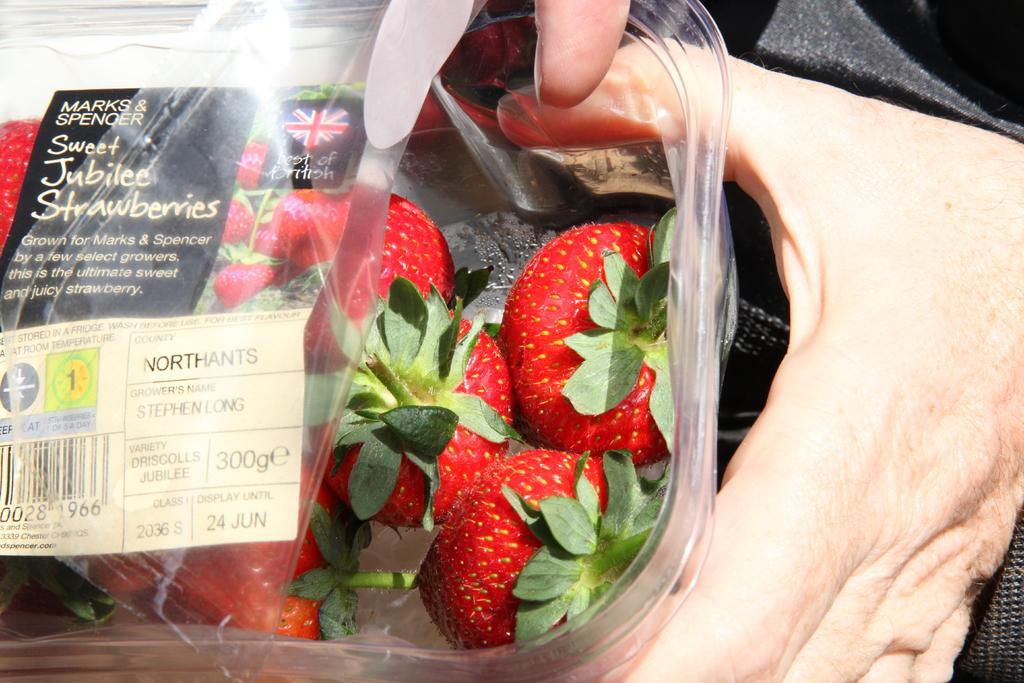In one or two sentences, can you explain what this image depicts? In the picture we can see a person is holding a box with strawberries in it and on the top of the box we can see a cover with a label on it. 